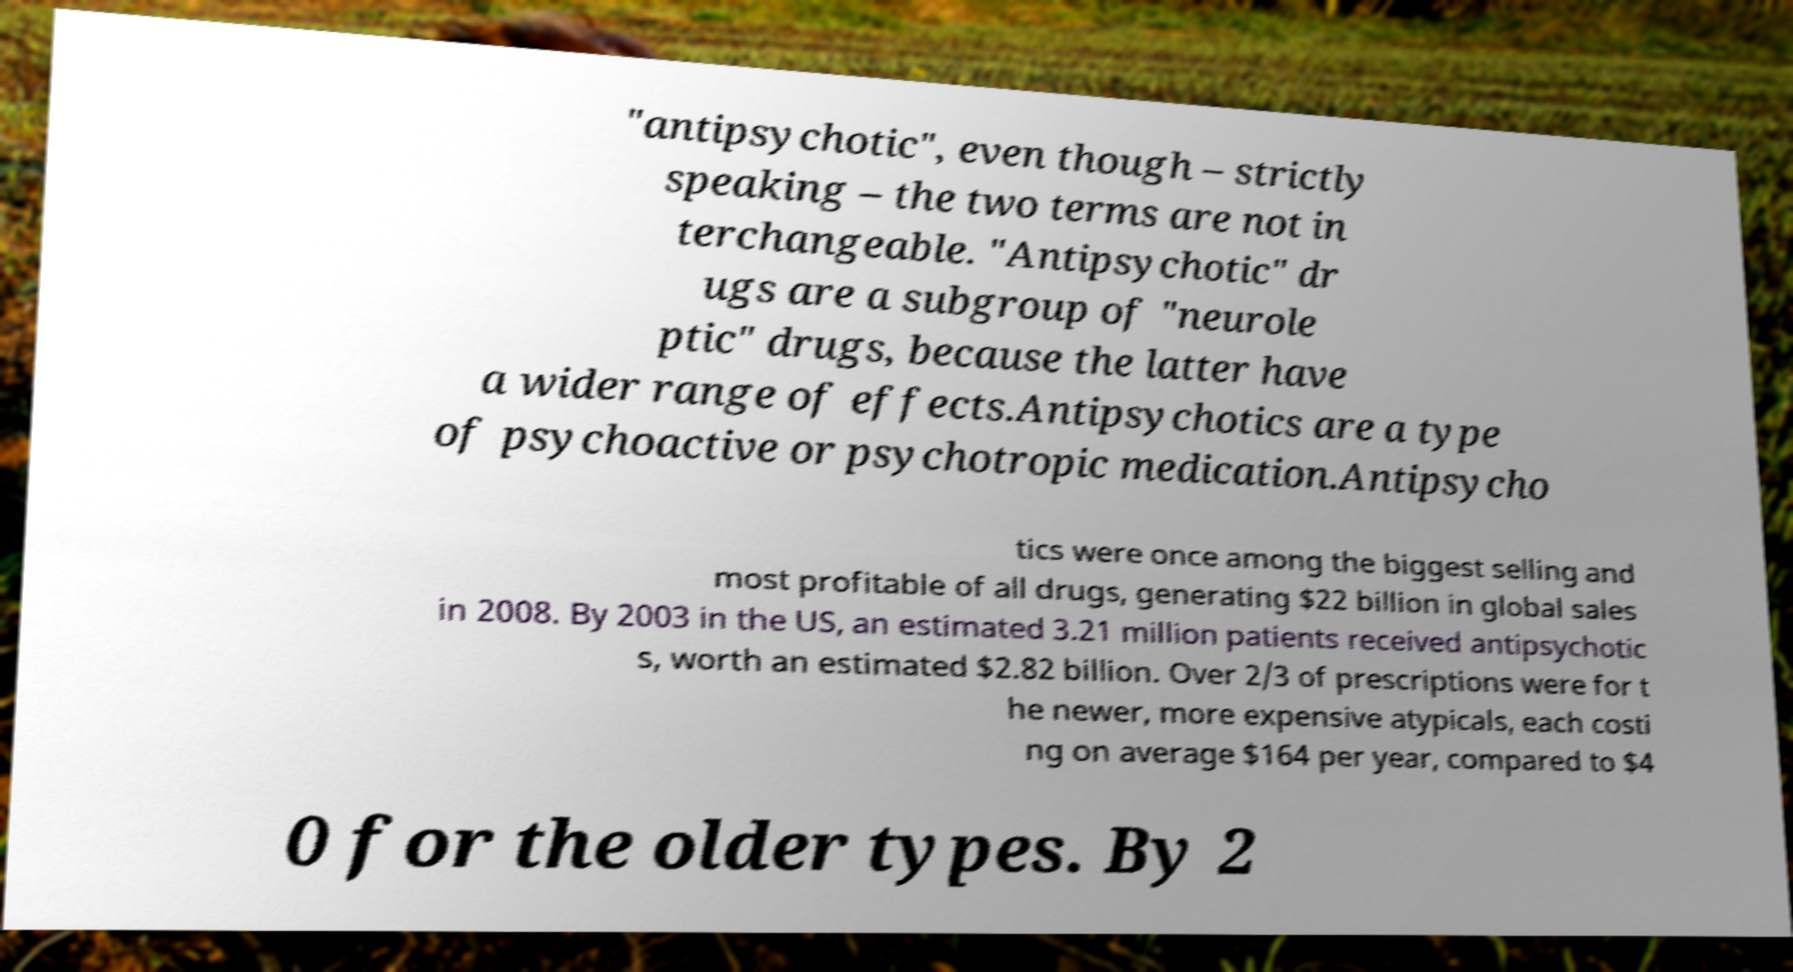Can you read and provide the text displayed in the image?This photo seems to have some interesting text. Can you extract and type it out for me? "antipsychotic", even though – strictly speaking – the two terms are not in terchangeable. "Antipsychotic" dr ugs are a subgroup of "neurole ptic" drugs, because the latter have a wider range of effects.Antipsychotics are a type of psychoactive or psychotropic medication.Antipsycho tics were once among the biggest selling and most profitable of all drugs, generating $22 billion in global sales in 2008. By 2003 in the US, an estimated 3.21 million patients received antipsychotic s, worth an estimated $2.82 billion. Over 2/3 of prescriptions were for t he newer, more expensive atypicals, each costi ng on average $164 per year, compared to $4 0 for the older types. By 2 